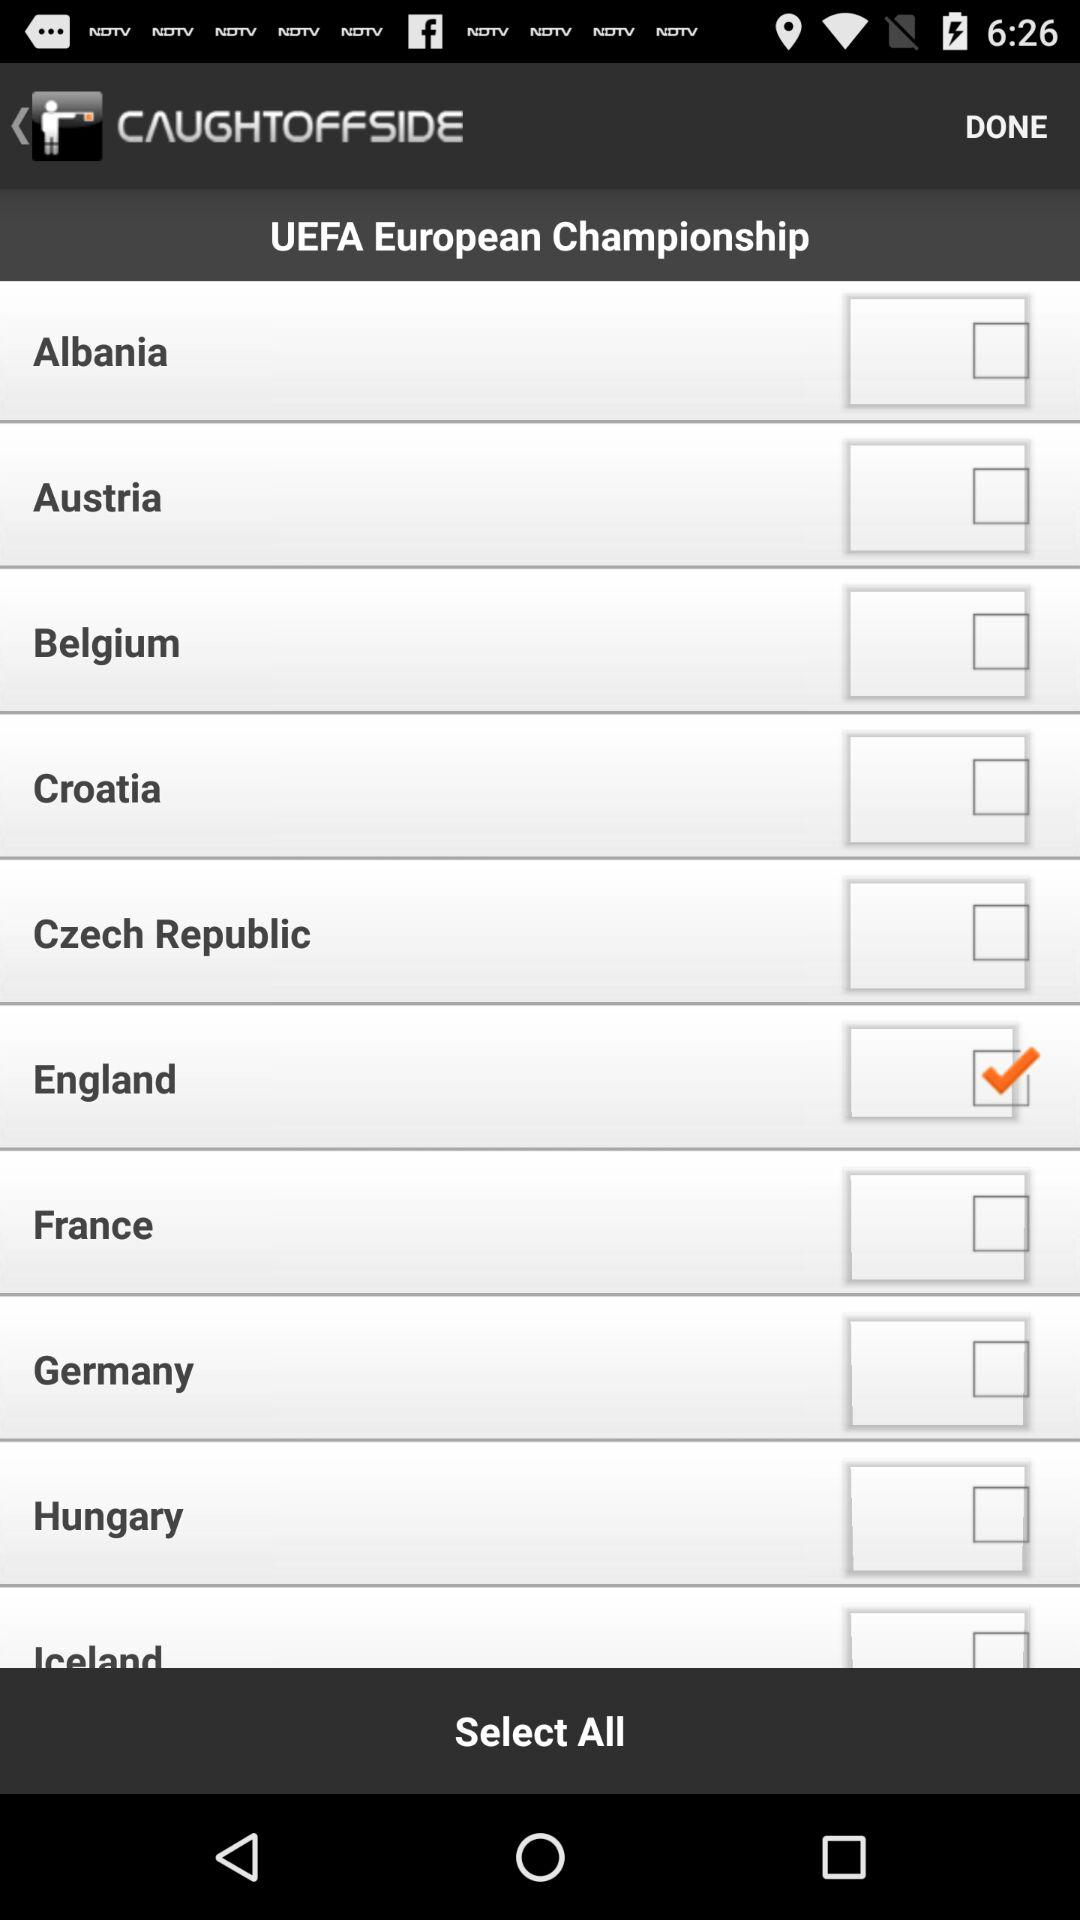What is the name of the application? The name of the application is "CAUGHTOFFSIDE". 